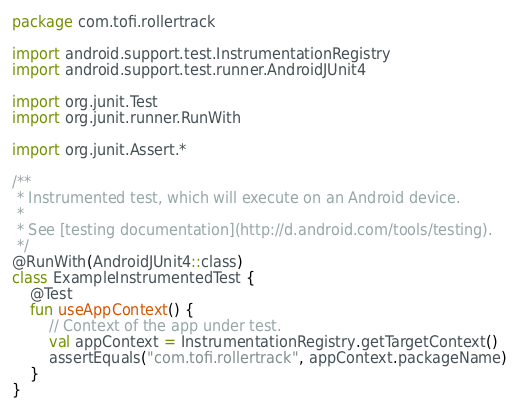<code> <loc_0><loc_0><loc_500><loc_500><_Kotlin_>package com.tofi.rollertrack

import android.support.test.InstrumentationRegistry
import android.support.test.runner.AndroidJUnit4

import org.junit.Test
import org.junit.runner.RunWith

import org.junit.Assert.*

/**
 * Instrumented test, which will execute on an Android device.
 *
 * See [testing documentation](http://d.android.com/tools/testing).
 */
@RunWith(AndroidJUnit4::class)
class ExampleInstrumentedTest {
    @Test
    fun useAppContext() {
        // Context of the app under test.
        val appContext = InstrumentationRegistry.getTargetContext()
        assertEquals("com.tofi.rollertrack", appContext.packageName)
    }
}
</code> 